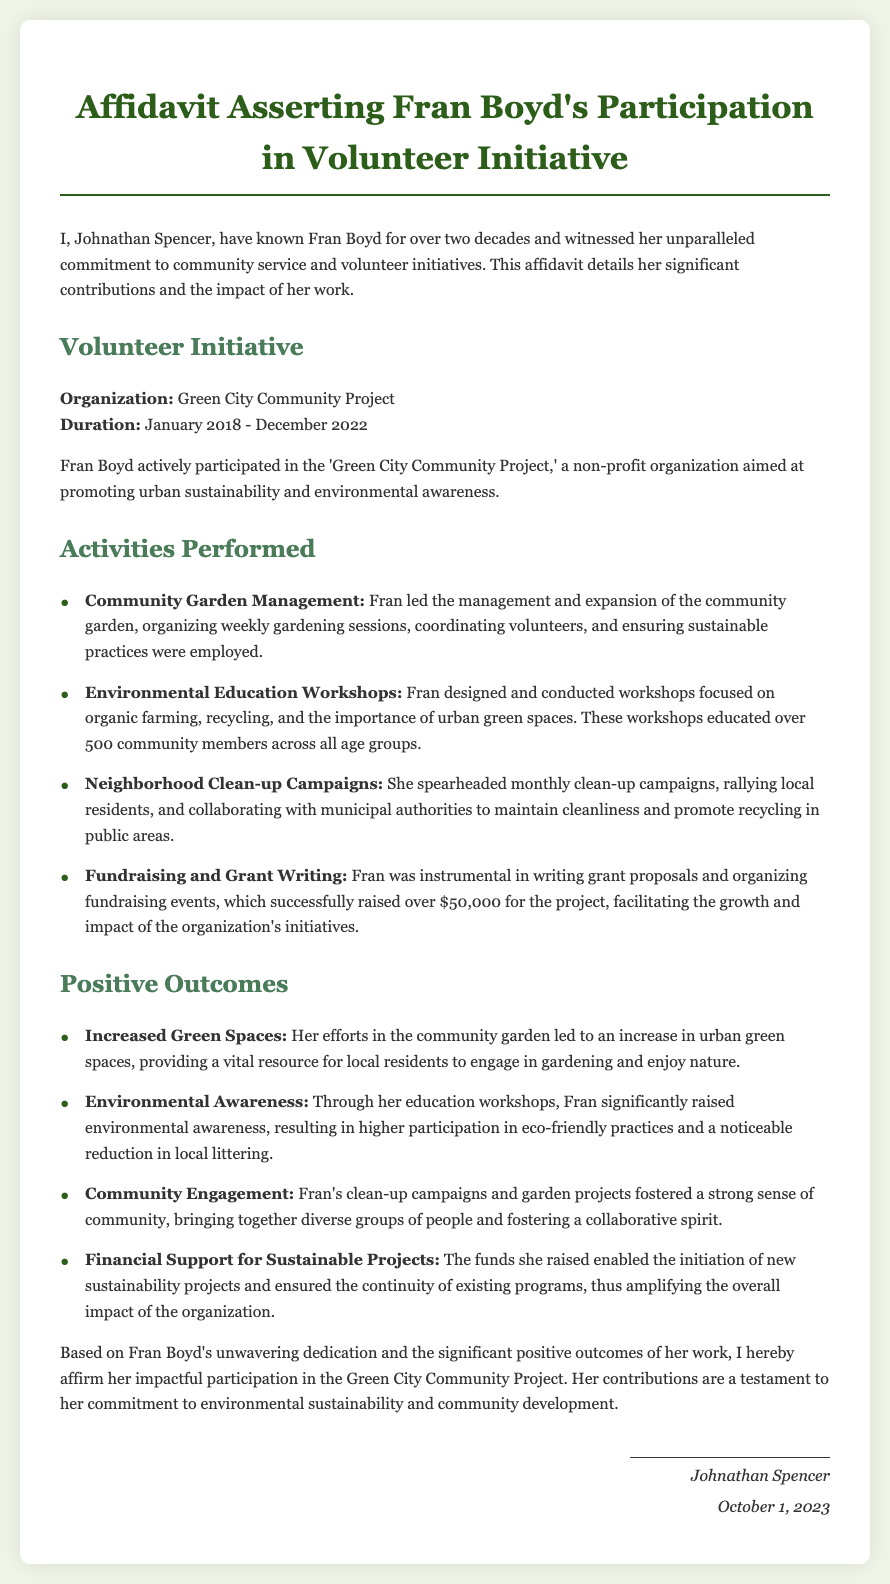What is the name of the organization Fran Boyd volunteered for? The organization Fran Boyd volunteered for is specified in the document as the Green City Community Project.
Answer: Green City Community Project What was the duration of Fran Boyd's volunteer involvement? The document states that her involvement lasted from January 2018 to December 2022.
Answer: January 2018 - December 2022 How many workshops did Fran Boyd conduct? The document indicates that her workshops educated over 500 community members, but it doesn't specifically mention the number of workshops conducted.
Answer: Not specified What amount did Fran Boyd help raise for the organization? The document lists that Fran Boyd successfully raised over $50,000 for the project through her efforts in fundraising and grant writing.
Answer: Over $50,000 What initiative did Fran lead in her volunteer role? The document describes Fran leading the management and expansion of the community garden as one of her key initiatives.
Answer: Community Garden Management What was one positive outcome of Fran's environmental education workshops? The document mentions that one positive outcome of Fran's workshops was a significant rise in environmental awareness among community members.
Answer: Environmental Awareness How often did Fran spearhead clean-up campaigns? According to the document, Fran spearheaded the clean-up campaigns monthly.
Answer: Monthly Who affirmed Fran Boyd's participation in the volunteer initiative? The document indicates that the person affirming Fran Boyd's participation is Johnathan Spencer.
Answer: Johnathan Spencer When was the affidavit signed? The document states that the affidavit was signed on October 1, 2023.
Answer: October 1, 2023 